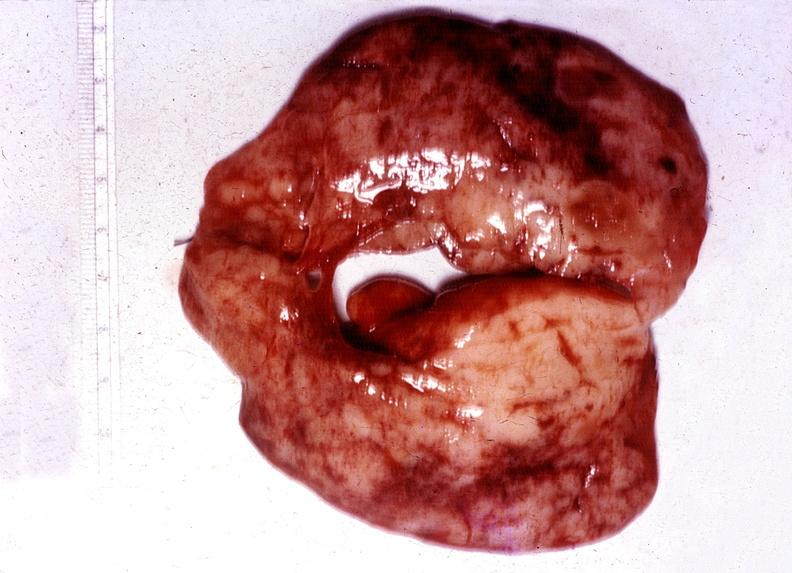does sacrococcygeal teratoma show thyroid, hashimotos?
Answer the question using a single word or phrase. No 